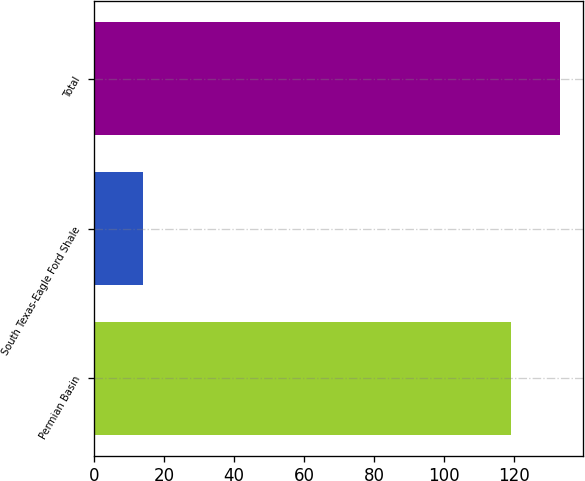Convert chart to OTSL. <chart><loc_0><loc_0><loc_500><loc_500><bar_chart><fcel>Permian Basin<fcel>South Texas-Eagle Ford Shale<fcel>Total<nl><fcel>119<fcel>14<fcel>133<nl></chart> 